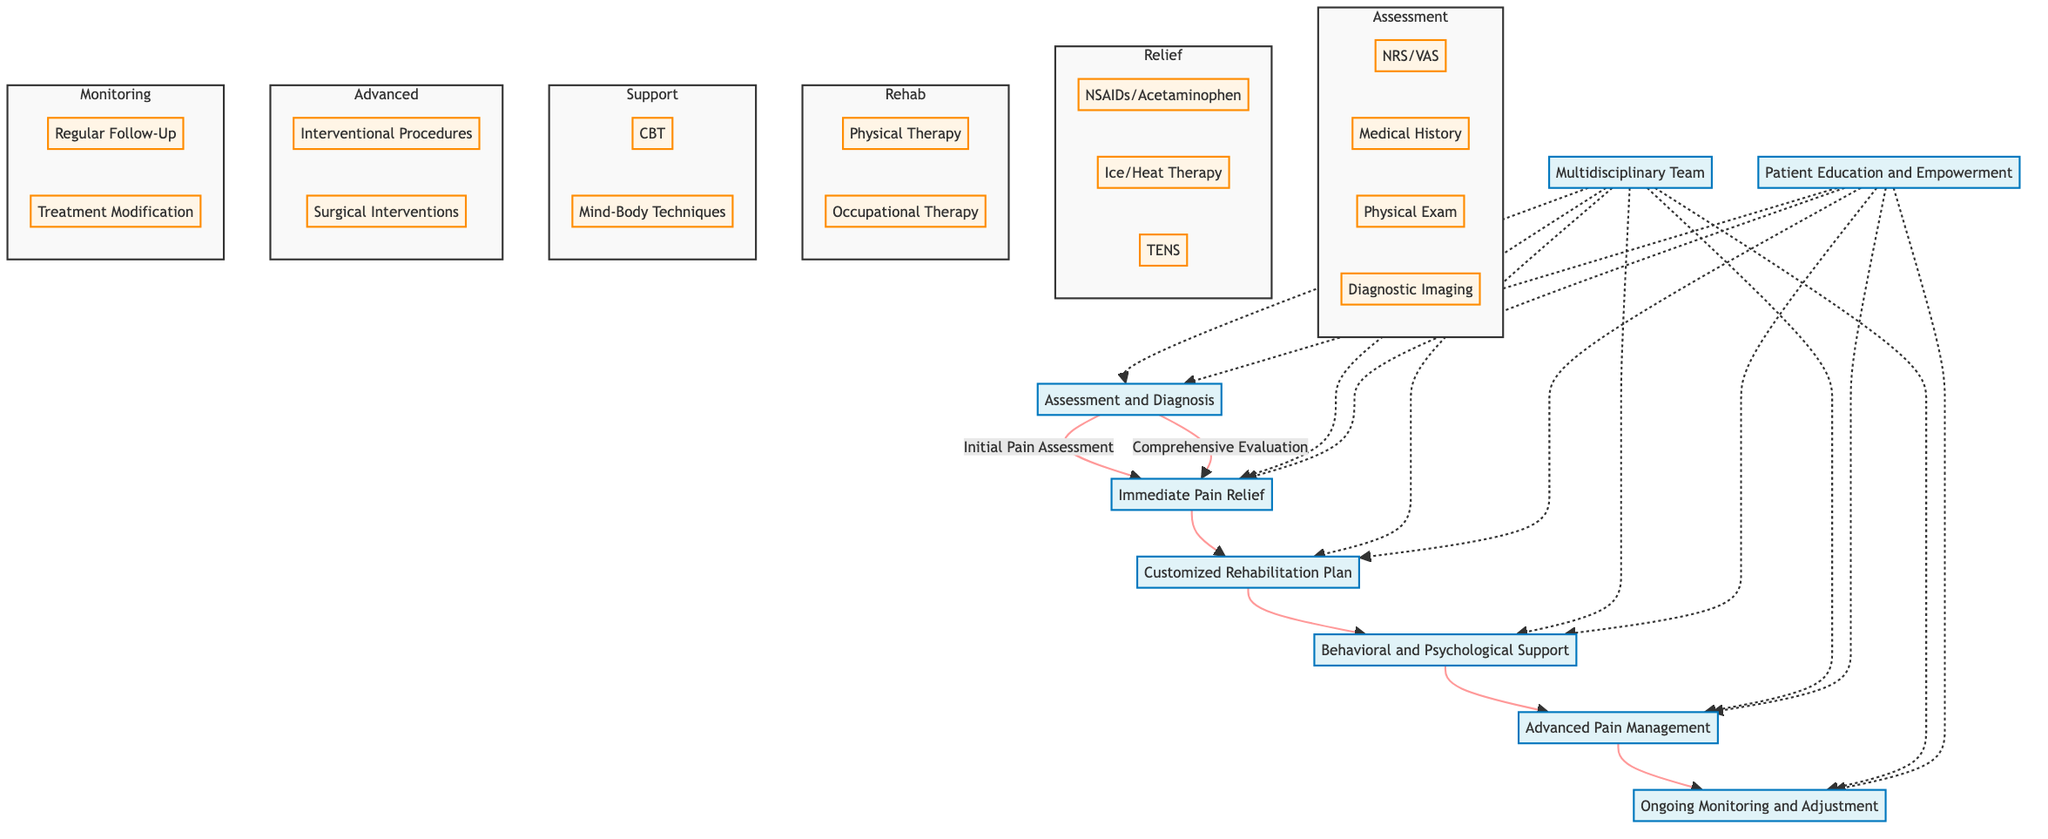What's the first step in the Pain Management Strategies pathway? The diagram indicates the first step is "Assessment and Diagnosis," which is the starting point of the rehabilitation pathway.
Answer: Assessment and Diagnosis How many main phases are there in the diagram? By counting the main blocks in the diagram, there are six phases: Assessment and Diagnosis, Immediate Pain Relief, Customized Rehabilitation Plan, Behavioral and Psychological Support, Advanced Pain Management, Ongoing Monitoring and Adjustment.
Answer: Six What interventions are included in Immediate Pain Relief? The diagram lists three interventions under Immediate Pain Relief: NSAIDs/Acetaminophen, Ice/Heat Therapy, and TENS.
Answer: NSAIDs/Acetaminophen, Ice/Heat Therapy, TENS What is the relationship between Customized Rehabilitation Plan and Behavioral and Psychological Support? The flow shows that Customized Rehabilitation Plan leads directly to Behavioral and Psychological Support, indicating that after the rehabilitation plan, this support is the next step.
Answer: Directly leads to What are the components of the Multidisciplinary Team? The diagram points out that the components of the Multidisciplinary Team include Pain Management Physicians, Physiotherapists, Psychologists, and Occupational Therapists.
Answer: Pain Management Physicians, Physiotherapists, Psychologists, Occupational Therapists What happens after Advanced Pain Management? According to the flowchart, the next step after Advanced Pain Management is Ongoing Monitoring and Adjustment, which follows as part of the rehabilitation process.
Answer: Ongoing Monitoring and Adjustment What type of interventions are included in Behavioral and Psychological Support? The diagram indicates there are two main types of interventions included: Cognitive Behavioral Therapy (CBT) and Mind-Body Techniques.
Answer: CBT, Mind-Body Techniques What is the purpose of the Patient Education and Empowerment phase? The purpose is to provide Self-Management Techniques and Education Sessions, enabling patients to take active roles in their rehabilitation.
Answer: Self-Management Techniques, Education Sessions Which interventions fall under Advanced Pain Management? The interventions listed in Advanced Pain Management are Interventional Procedures and Surgical Interventions, indicating more invasive strategies for pain relief.
Answer: Interventional Procedures, Surgical Interventions 